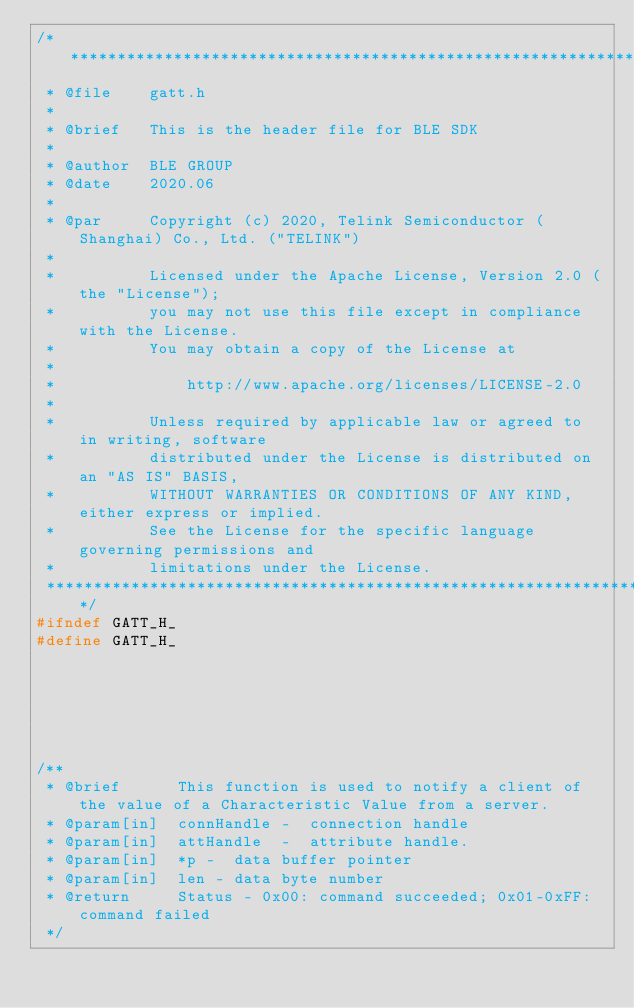Convert code to text. <code><loc_0><loc_0><loc_500><loc_500><_C_>/********************************************************************************************************
 * @file	gatt.h
 *
 * @brief	This is the header file for BLE SDK
 *
 * @author	BLE GROUP
 * @date	2020.06
 *
 * @par     Copyright (c) 2020, Telink Semiconductor (Shanghai) Co., Ltd. ("TELINK")
 *
 *          Licensed under the Apache License, Version 2.0 (the "License");
 *          you may not use this file except in compliance with the License.
 *          You may obtain a copy of the License at
 *
 *              http://www.apache.org/licenses/LICENSE-2.0
 *
 *          Unless required by applicable law or agreed to in writing, software
 *          distributed under the License is distributed on an "AS IS" BASIS,
 *          WITHOUT WARRANTIES OR CONDITIONS OF ANY KIND, either express or implied.
 *          See the License for the specific language governing permissions and
 *          limitations under the License.
 *******************************************************************************************************/
#ifndef GATT_H_
#define GATT_H_






/**
 * @brief	   This function is used to notify a client of the value of a Characteristic Value from a server.
 * @param[in]  connHandle -  connection handle
 * @param[in]  attHandle  -  attribute handle.
 * @param[in]  *p -  data buffer pointer
 * @param[in]  len - data byte number
 * @return     Status - 0x00: command succeeded; 0x01-0xFF: command failed
 */</code> 